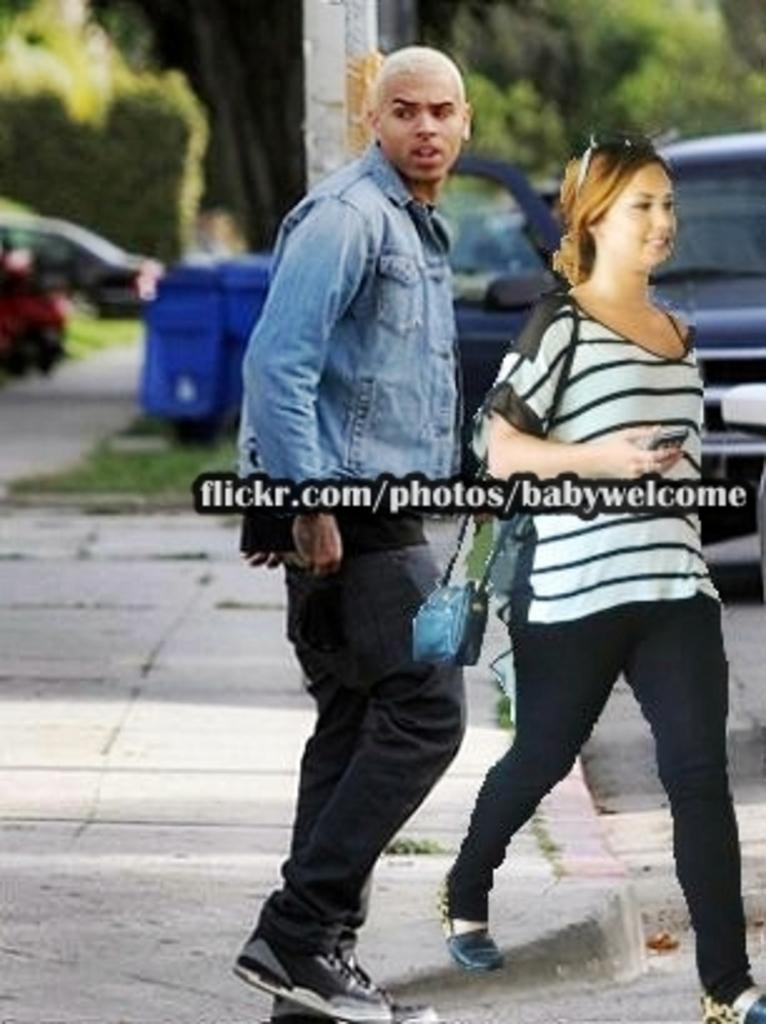<image>
Create a compact narrative representing the image presented. From flickr.com, appears to be photo shopped with the tag baby welcome. 